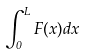Convert formula to latex. <formula><loc_0><loc_0><loc_500><loc_500>\int _ { 0 } ^ { L } F ( x ) d x</formula> 